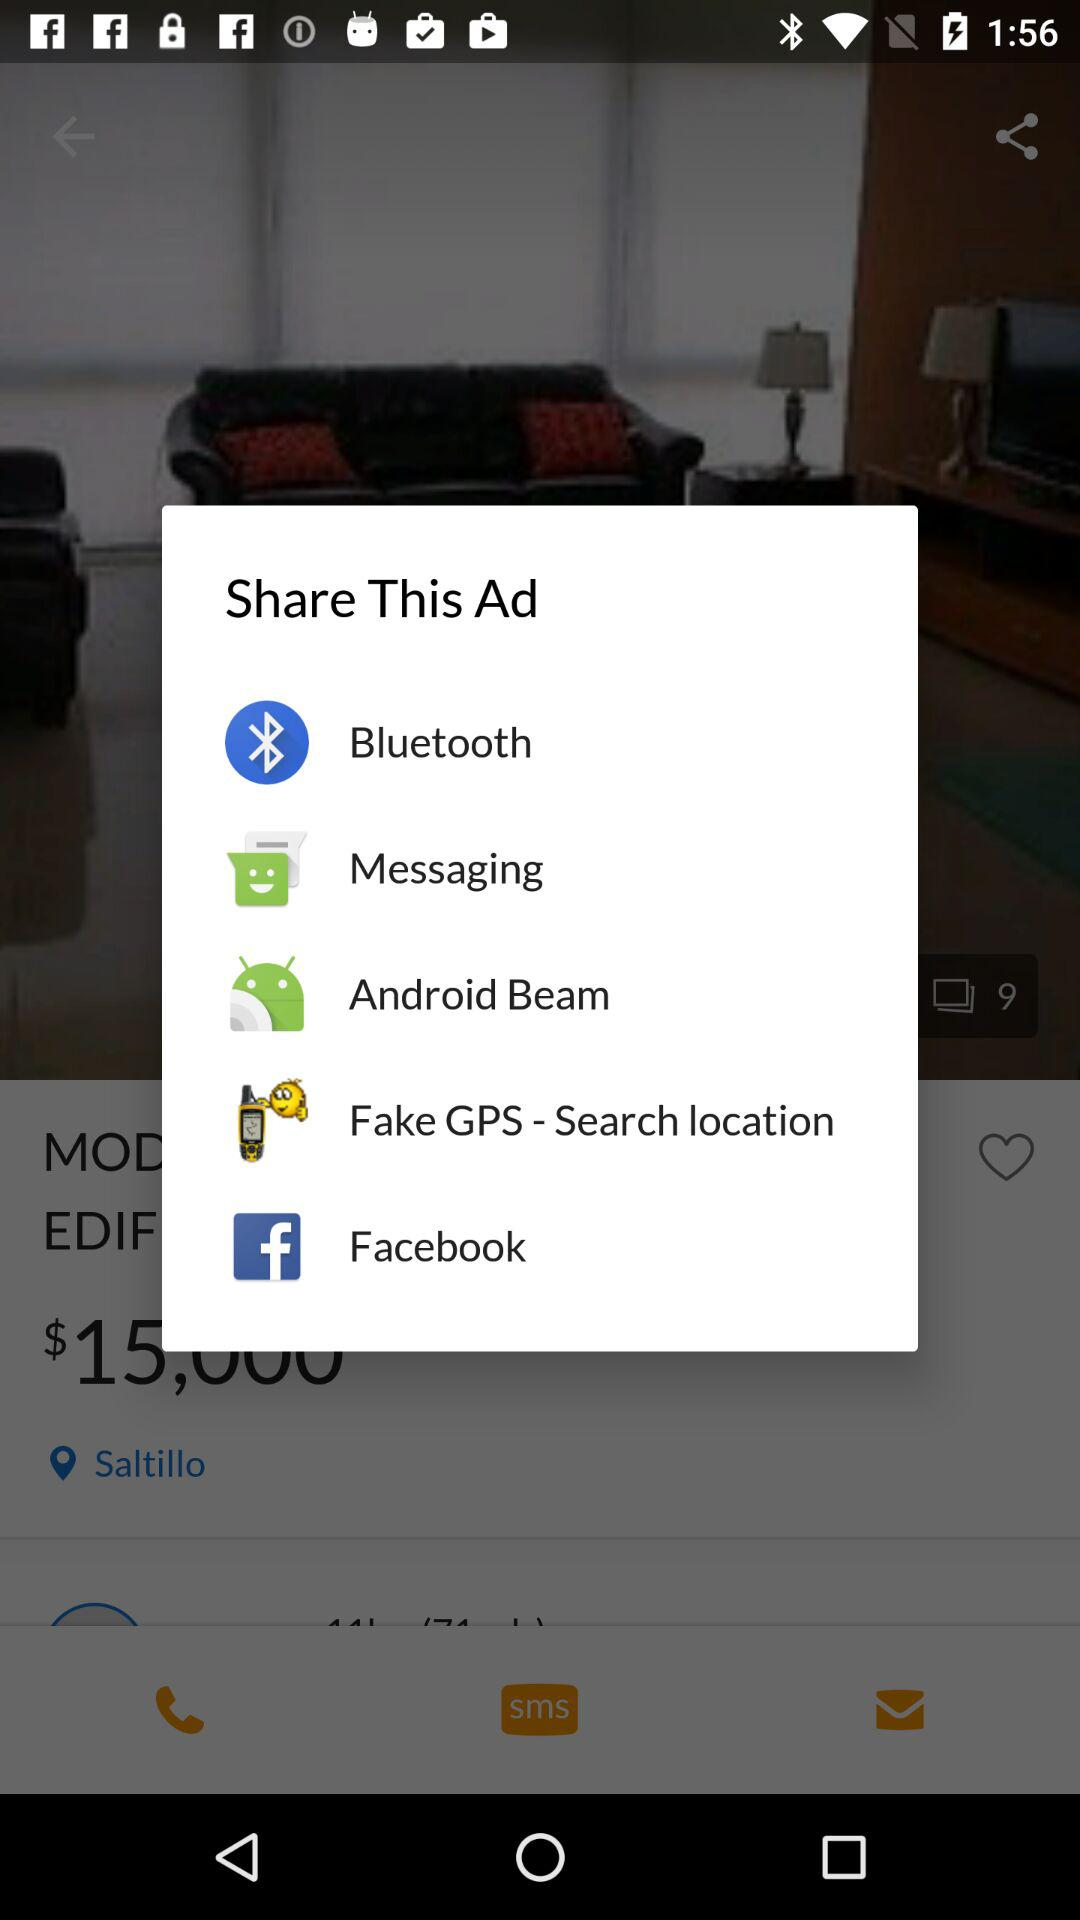What applications can be used to share this ad? You can share it with Bluetooth, Messaging, Android Beam, Fake GPS - Search location and Facebook. 